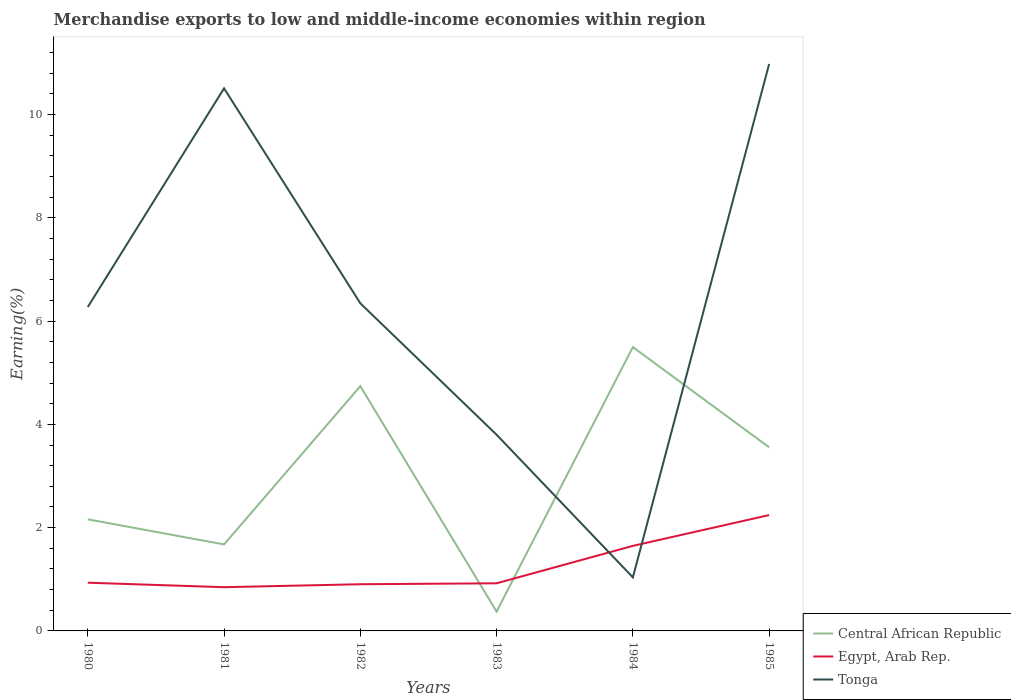Across all years, what is the maximum percentage of amount earned from merchandise exports in Egypt, Arab Rep.?
Provide a short and direct response. 0.85. What is the total percentage of amount earned from merchandise exports in Central African Republic in the graph?
Offer a terse response. 0.49. What is the difference between the highest and the second highest percentage of amount earned from merchandise exports in Central African Republic?
Ensure brevity in your answer.  5.12. Is the percentage of amount earned from merchandise exports in Tonga strictly greater than the percentage of amount earned from merchandise exports in Central African Republic over the years?
Your answer should be very brief. No. How many lines are there?
Offer a very short reply. 3. How many years are there in the graph?
Your response must be concise. 6. Does the graph contain any zero values?
Ensure brevity in your answer.  No. Does the graph contain grids?
Ensure brevity in your answer.  No. How are the legend labels stacked?
Your response must be concise. Vertical. What is the title of the graph?
Keep it short and to the point. Merchandise exports to low and middle-income economies within region. What is the label or title of the Y-axis?
Your response must be concise. Earning(%). What is the Earning(%) in Central African Republic in 1980?
Provide a short and direct response. 2.16. What is the Earning(%) in Egypt, Arab Rep. in 1980?
Provide a short and direct response. 0.93. What is the Earning(%) of Tonga in 1980?
Keep it short and to the point. 6.27. What is the Earning(%) of Central African Republic in 1981?
Offer a very short reply. 1.68. What is the Earning(%) in Egypt, Arab Rep. in 1981?
Your answer should be compact. 0.85. What is the Earning(%) of Tonga in 1981?
Provide a short and direct response. 10.51. What is the Earning(%) of Central African Republic in 1982?
Make the answer very short. 4.74. What is the Earning(%) of Egypt, Arab Rep. in 1982?
Provide a short and direct response. 0.9. What is the Earning(%) in Tonga in 1982?
Offer a very short reply. 6.34. What is the Earning(%) of Central African Republic in 1983?
Keep it short and to the point. 0.37. What is the Earning(%) in Egypt, Arab Rep. in 1983?
Keep it short and to the point. 0.92. What is the Earning(%) in Tonga in 1983?
Provide a short and direct response. 3.8. What is the Earning(%) of Central African Republic in 1984?
Your answer should be very brief. 5.5. What is the Earning(%) of Egypt, Arab Rep. in 1984?
Keep it short and to the point. 1.65. What is the Earning(%) in Tonga in 1984?
Your response must be concise. 1.04. What is the Earning(%) in Central African Republic in 1985?
Keep it short and to the point. 3.56. What is the Earning(%) of Egypt, Arab Rep. in 1985?
Offer a terse response. 2.24. What is the Earning(%) of Tonga in 1985?
Make the answer very short. 10.98. Across all years, what is the maximum Earning(%) of Central African Republic?
Make the answer very short. 5.5. Across all years, what is the maximum Earning(%) of Egypt, Arab Rep.?
Give a very brief answer. 2.24. Across all years, what is the maximum Earning(%) in Tonga?
Offer a terse response. 10.98. Across all years, what is the minimum Earning(%) of Central African Republic?
Provide a short and direct response. 0.37. Across all years, what is the minimum Earning(%) of Egypt, Arab Rep.?
Your answer should be compact. 0.85. Across all years, what is the minimum Earning(%) of Tonga?
Your answer should be very brief. 1.04. What is the total Earning(%) in Central African Republic in the graph?
Keep it short and to the point. 18. What is the total Earning(%) in Egypt, Arab Rep. in the graph?
Make the answer very short. 7.5. What is the total Earning(%) of Tonga in the graph?
Keep it short and to the point. 38.94. What is the difference between the Earning(%) of Central African Republic in 1980 and that in 1981?
Offer a terse response. 0.49. What is the difference between the Earning(%) of Egypt, Arab Rep. in 1980 and that in 1981?
Provide a succinct answer. 0.09. What is the difference between the Earning(%) of Tonga in 1980 and that in 1981?
Your response must be concise. -4.24. What is the difference between the Earning(%) of Central African Republic in 1980 and that in 1982?
Provide a short and direct response. -2.58. What is the difference between the Earning(%) of Egypt, Arab Rep. in 1980 and that in 1982?
Ensure brevity in your answer.  0.03. What is the difference between the Earning(%) in Tonga in 1980 and that in 1982?
Offer a terse response. -0.07. What is the difference between the Earning(%) in Central African Republic in 1980 and that in 1983?
Your answer should be very brief. 1.79. What is the difference between the Earning(%) of Egypt, Arab Rep. in 1980 and that in 1983?
Offer a very short reply. 0.01. What is the difference between the Earning(%) of Tonga in 1980 and that in 1983?
Your answer should be very brief. 2.47. What is the difference between the Earning(%) of Central African Republic in 1980 and that in 1984?
Your response must be concise. -3.34. What is the difference between the Earning(%) of Egypt, Arab Rep. in 1980 and that in 1984?
Provide a succinct answer. -0.71. What is the difference between the Earning(%) of Tonga in 1980 and that in 1984?
Provide a short and direct response. 5.24. What is the difference between the Earning(%) in Central African Republic in 1980 and that in 1985?
Ensure brevity in your answer.  -1.39. What is the difference between the Earning(%) of Egypt, Arab Rep. in 1980 and that in 1985?
Offer a terse response. -1.31. What is the difference between the Earning(%) of Tonga in 1980 and that in 1985?
Your answer should be very brief. -4.71. What is the difference between the Earning(%) in Central African Republic in 1981 and that in 1982?
Provide a short and direct response. -3.07. What is the difference between the Earning(%) in Egypt, Arab Rep. in 1981 and that in 1982?
Your answer should be compact. -0.06. What is the difference between the Earning(%) of Tonga in 1981 and that in 1982?
Ensure brevity in your answer.  4.16. What is the difference between the Earning(%) in Central African Republic in 1981 and that in 1983?
Offer a very short reply. 1.3. What is the difference between the Earning(%) in Egypt, Arab Rep. in 1981 and that in 1983?
Keep it short and to the point. -0.08. What is the difference between the Earning(%) in Tonga in 1981 and that in 1983?
Provide a succinct answer. 6.71. What is the difference between the Earning(%) in Central African Republic in 1981 and that in 1984?
Offer a very short reply. -3.82. What is the difference between the Earning(%) of Egypt, Arab Rep. in 1981 and that in 1984?
Provide a succinct answer. -0.8. What is the difference between the Earning(%) in Tonga in 1981 and that in 1984?
Your response must be concise. 9.47. What is the difference between the Earning(%) in Central African Republic in 1981 and that in 1985?
Provide a short and direct response. -1.88. What is the difference between the Earning(%) in Egypt, Arab Rep. in 1981 and that in 1985?
Make the answer very short. -1.4. What is the difference between the Earning(%) in Tonga in 1981 and that in 1985?
Keep it short and to the point. -0.47. What is the difference between the Earning(%) in Central African Republic in 1982 and that in 1983?
Offer a terse response. 4.37. What is the difference between the Earning(%) in Egypt, Arab Rep. in 1982 and that in 1983?
Your answer should be very brief. -0.02. What is the difference between the Earning(%) of Tonga in 1982 and that in 1983?
Offer a very short reply. 2.55. What is the difference between the Earning(%) of Central African Republic in 1982 and that in 1984?
Give a very brief answer. -0.76. What is the difference between the Earning(%) of Egypt, Arab Rep. in 1982 and that in 1984?
Your response must be concise. -0.74. What is the difference between the Earning(%) in Tonga in 1982 and that in 1984?
Make the answer very short. 5.31. What is the difference between the Earning(%) of Central African Republic in 1982 and that in 1985?
Offer a terse response. 1.18. What is the difference between the Earning(%) in Egypt, Arab Rep. in 1982 and that in 1985?
Offer a terse response. -1.34. What is the difference between the Earning(%) of Tonga in 1982 and that in 1985?
Provide a succinct answer. -4.64. What is the difference between the Earning(%) of Central African Republic in 1983 and that in 1984?
Provide a short and direct response. -5.12. What is the difference between the Earning(%) in Egypt, Arab Rep. in 1983 and that in 1984?
Ensure brevity in your answer.  -0.72. What is the difference between the Earning(%) in Tonga in 1983 and that in 1984?
Your answer should be very brief. 2.76. What is the difference between the Earning(%) of Central African Republic in 1983 and that in 1985?
Your answer should be very brief. -3.18. What is the difference between the Earning(%) in Egypt, Arab Rep. in 1983 and that in 1985?
Offer a terse response. -1.32. What is the difference between the Earning(%) of Tonga in 1983 and that in 1985?
Offer a very short reply. -7.18. What is the difference between the Earning(%) in Central African Republic in 1984 and that in 1985?
Offer a very short reply. 1.94. What is the difference between the Earning(%) in Egypt, Arab Rep. in 1984 and that in 1985?
Make the answer very short. -0.6. What is the difference between the Earning(%) in Tonga in 1984 and that in 1985?
Offer a terse response. -9.94. What is the difference between the Earning(%) of Central African Republic in 1980 and the Earning(%) of Egypt, Arab Rep. in 1981?
Your answer should be compact. 1.31. What is the difference between the Earning(%) of Central African Republic in 1980 and the Earning(%) of Tonga in 1981?
Keep it short and to the point. -8.35. What is the difference between the Earning(%) in Egypt, Arab Rep. in 1980 and the Earning(%) in Tonga in 1981?
Make the answer very short. -9.57. What is the difference between the Earning(%) of Central African Republic in 1980 and the Earning(%) of Egypt, Arab Rep. in 1982?
Ensure brevity in your answer.  1.26. What is the difference between the Earning(%) in Central African Republic in 1980 and the Earning(%) in Tonga in 1982?
Your answer should be compact. -4.18. What is the difference between the Earning(%) of Egypt, Arab Rep. in 1980 and the Earning(%) of Tonga in 1982?
Your answer should be very brief. -5.41. What is the difference between the Earning(%) of Central African Republic in 1980 and the Earning(%) of Egypt, Arab Rep. in 1983?
Your answer should be compact. 1.24. What is the difference between the Earning(%) of Central African Republic in 1980 and the Earning(%) of Tonga in 1983?
Make the answer very short. -1.64. What is the difference between the Earning(%) of Egypt, Arab Rep. in 1980 and the Earning(%) of Tonga in 1983?
Make the answer very short. -2.87. What is the difference between the Earning(%) of Central African Republic in 1980 and the Earning(%) of Egypt, Arab Rep. in 1984?
Give a very brief answer. 0.51. What is the difference between the Earning(%) in Central African Republic in 1980 and the Earning(%) in Tonga in 1984?
Your answer should be very brief. 1.12. What is the difference between the Earning(%) in Egypt, Arab Rep. in 1980 and the Earning(%) in Tonga in 1984?
Keep it short and to the point. -0.1. What is the difference between the Earning(%) of Central African Republic in 1980 and the Earning(%) of Egypt, Arab Rep. in 1985?
Your answer should be very brief. -0.08. What is the difference between the Earning(%) in Central African Republic in 1980 and the Earning(%) in Tonga in 1985?
Give a very brief answer. -8.82. What is the difference between the Earning(%) in Egypt, Arab Rep. in 1980 and the Earning(%) in Tonga in 1985?
Provide a succinct answer. -10.05. What is the difference between the Earning(%) in Central African Republic in 1981 and the Earning(%) in Egypt, Arab Rep. in 1982?
Provide a succinct answer. 0.77. What is the difference between the Earning(%) in Central African Republic in 1981 and the Earning(%) in Tonga in 1982?
Your answer should be very brief. -4.67. What is the difference between the Earning(%) in Egypt, Arab Rep. in 1981 and the Earning(%) in Tonga in 1982?
Make the answer very short. -5.5. What is the difference between the Earning(%) of Central African Republic in 1981 and the Earning(%) of Egypt, Arab Rep. in 1983?
Give a very brief answer. 0.75. What is the difference between the Earning(%) in Central African Republic in 1981 and the Earning(%) in Tonga in 1983?
Your answer should be very brief. -2.12. What is the difference between the Earning(%) in Egypt, Arab Rep. in 1981 and the Earning(%) in Tonga in 1983?
Offer a terse response. -2.95. What is the difference between the Earning(%) in Central African Republic in 1981 and the Earning(%) in Egypt, Arab Rep. in 1984?
Provide a succinct answer. 0.03. What is the difference between the Earning(%) of Central African Republic in 1981 and the Earning(%) of Tonga in 1984?
Your answer should be very brief. 0.64. What is the difference between the Earning(%) in Egypt, Arab Rep. in 1981 and the Earning(%) in Tonga in 1984?
Make the answer very short. -0.19. What is the difference between the Earning(%) of Central African Republic in 1981 and the Earning(%) of Egypt, Arab Rep. in 1985?
Keep it short and to the point. -0.57. What is the difference between the Earning(%) in Central African Republic in 1981 and the Earning(%) in Tonga in 1985?
Give a very brief answer. -9.31. What is the difference between the Earning(%) of Egypt, Arab Rep. in 1981 and the Earning(%) of Tonga in 1985?
Keep it short and to the point. -10.13. What is the difference between the Earning(%) in Central African Republic in 1982 and the Earning(%) in Egypt, Arab Rep. in 1983?
Offer a very short reply. 3.82. What is the difference between the Earning(%) of Central African Republic in 1982 and the Earning(%) of Tonga in 1983?
Make the answer very short. 0.94. What is the difference between the Earning(%) of Egypt, Arab Rep. in 1982 and the Earning(%) of Tonga in 1983?
Offer a terse response. -2.9. What is the difference between the Earning(%) of Central African Republic in 1982 and the Earning(%) of Egypt, Arab Rep. in 1984?
Offer a very short reply. 3.09. What is the difference between the Earning(%) of Central African Republic in 1982 and the Earning(%) of Tonga in 1984?
Ensure brevity in your answer.  3.7. What is the difference between the Earning(%) of Egypt, Arab Rep. in 1982 and the Earning(%) of Tonga in 1984?
Your answer should be very brief. -0.13. What is the difference between the Earning(%) in Central African Republic in 1982 and the Earning(%) in Egypt, Arab Rep. in 1985?
Keep it short and to the point. 2.5. What is the difference between the Earning(%) of Central African Republic in 1982 and the Earning(%) of Tonga in 1985?
Provide a succinct answer. -6.24. What is the difference between the Earning(%) of Egypt, Arab Rep. in 1982 and the Earning(%) of Tonga in 1985?
Offer a very short reply. -10.08. What is the difference between the Earning(%) of Central African Republic in 1983 and the Earning(%) of Egypt, Arab Rep. in 1984?
Provide a succinct answer. -1.27. What is the difference between the Earning(%) in Central African Republic in 1983 and the Earning(%) in Tonga in 1984?
Offer a terse response. -0.66. What is the difference between the Earning(%) of Egypt, Arab Rep. in 1983 and the Earning(%) of Tonga in 1984?
Offer a terse response. -0.11. What is the difference between the Earning(%) of Central African Republic in 1983 and the Earning(%) of Egypt, Arab Rep. in 1985?
Ensure brevity in your answer.  -1.87. What is the difference between the Earning(%) in Central African Republic in 1983 and the Earning(%) in Tonga in 1985?
Offer a very short reply. -10.61. What is the difference between the Earning(%) in Egypt, Arab Rep. in 1983 and the Earning(%) in Tonga in 1985?
Your response must be concise. -10.06. What is the difference between the Earning(%) in Central African Republic in 1984 and the Earning(%) in Egypt, Arab Rep. in 1985?
Your response must be concise. 3.25. What is the difference between the Earning(%) in Central African Republic in 1984 and the Earning(%) in Tonga in 1985?
Keep it short and to the point. -5.48. What is the difference between the Earning(%) in Egypt, Arab Rep. in 1984 and the Earning(%) in Tonga in 1985?
Give a very brief answer. -9.33. What is the average Earning(%) of Central African Republic per year?
Make the answer very short. 3. What is the average Earning(%) of Egypt, Arab Rep. per year?
Offer a very short reply. 1.25. What is the average Earning(%) in Tonga per year?
Offer a terse response. 6.49. In the year 1980, what is the difference between the Earning(%) of Central African Republic and Earning(%) of Egypt, Arab Rep.?
Offer a very short reply. 1.23. In the year 1980, what is the difference between the Earning(%) in Central African Republic and Earning(%) in Tonga?
Offer a very short reply. -4.11. In the year 1980, what is the difference between the Earning(%) in Egypt, Arab Rep. and Earning(%) in Tonga?
Ensure brevity in your answer.  -5.34. In the year 1981, what is the difference between the Earning(%) in Central African Republic and Earning(%) in Egypt, Arab Rep.?
Keep it short and to the point. 0.83. In the year 1981, what is the difference between the Earning(%) in Central African Republic and Earning(%) in Tonga?
Your answer should be very brief. -8.83. In the year 1981, what is the difference between the Earning(%) of Egypt, Arab Rep. and Earning(%) of Tonga?
Offer a very short reply. -9.66. In the year 1982, what is the difference between the Earning(%) in Central African Republic and Earning(%) in Egypt, Arab Rep.?
Keep it short and to the point. 3.84. In the year 1982, what is the difference between the Earning(%) in Central African Republic and Earning(%) in Tonga?
Keep it short and to the point. -1.6. In the year 1982, what is the difference between the Earning(%) of Egypt, Arab Rep. and Earning(%) of Tonga?
Give a very brief answer. -5.44. In the year 1983, what is the difference between the Earning(%) in Central African Republic and Earning(%) in Egypt, Arab Rep.?
Give a very brief answer. -0.55. In the year 1983, what is the difference between the Earning(%) of Central African Republic and Earning(%) of Tonga?
Your answer should be compact. -3.43. In the year 1983, what is the difference between the Earning(%) in Egypt, Arab Rep. and Earning(%) in Tonga?
Offer a very short reply. -2.88. In the year 1984, what is the difference between the Earning(%) in Central African Republic and Earning(%) in Egypt, Arab Rep.?
Provide a short and direct response. 3.85. In the year 1984, what is the difference between the Earning(%) in Central African Republic and Earning(%) in Tonga?
Provide a succinct answer. 4.46. In the year 1984, what is the difference between the Earning(%) of Egypt, Arab Rep. and Earning(%) of Tonga?
Provide a succinct answer. 0.61. In the year 1985, what is the difference between the Earning(%) of Central African Republic and Earning(%) of Egypt, Arab Rep.?
Your response must be concise. 1.31. In the year 1985, what is the difference between the Earning(%) in Central African Republic and Earning(%) in Tonga?
Give a very brief answer. -7.42. In the year 1985, what is the difference between the Earning(%) in Egypt, Arab Rep. and Earning(%) in Tonga?
Give a very brief answer. -8.74. What is the ratio of the Earning(%) in Central African Republic in 1980 to that in 1981?
Provide a succinct answer. 1.29. What is the ratio of the Earning(%) of Egypt, Arab Rep. in 1980 to that in 1981?
Make the answer very short. 1.1. What is the ratio of the Earning(%) of Tonga in 1980 to that in 1981?
Make the answer very short. 0.6. What is the ratio of the Earning(%) in Central African Republic in 1980 to that in 1982?
Give a very brief answer. 0.46. What is the ratio of the Earning(%) of Egypt, Arab Rep. in 1980 to that in 1982?
Your response must be concise. 1.03. What is the ratio of the Earning(%) in Tonga in 1980 to that in 1982?
Provide a succinct answer. 0.99. What is the ratio of the Earning(%) in Central African Republic in 1980 to that in 1983?
Give a very brief answer. 5.77. What is the ratio of the Earning(%) of Egypt, Arab Rep. in 1980 to that in 1983?
Provide a short and direct response. 1.01. What is the ratio of the Earning(%) in Tonga in 1980 to that in 1983?
Provide a succinct answer. 1.65. What is the ratio of the Earning(%) of Central African Republic in 1980 to that in 1984?
Your answer should be very brief. 0.39. What is the ratio of the Earning(%) of Egypt, Arab Rep. in 1980 to that in 1984?
Offer a very short reply. 0.57. What is the ratio of the Earning(%) in Tonga in 1980 to that in 1984?
Your answer should be compact. 6.05. What is the ratio of the Earning(%) of Central African Republic in 1980 to that in 1985?
Ensure brevity in your answer.  0.61. What is the ratio of the Earning(%) in Egypt, Arab Rep. in 1980 to that in 1985?
Provide a short and direct response. 0.42. What is the ratio of the Earning(%) of Tonga in 1980 to that in 1985?
Provide a short and direct response. 0.57. What is the ratio of the Earning(%) in Central African Republic in 1981 to that in 1982?
Offer a very short reply. 0.35. What is the ratio of the Earning(%) of Egypt, Arab Rep. in 1981 to that in 1982?
Your answer should be compact. 0.94. What is the ratio of the Earning(%) in Tonga in 1981 to that in 1982?
Ensure brevity in your answer.  1.66. What is the ratio of the Earning(%) in Central African Republic in 1981 to that in 1983?
Give a very brief answer. 4.47. What is the ratio of the Earning(%) in Egypt, Arab Rep. in 1981 to that in 1983?
Your answer should be very brief. 0.92. What is the ratio of the Earning(%) of Tonga in 1981 to that in 1983?
Make the answer very short. 2.77. What is the ratio of the Earning(%) in Central African Republic in 1981 to that in 1984?
Offer a very short reply. 0.3. What is the ratio of the Earning(%) of Egypt, Arab Rep. in 1981 to that in 1984?
Keep it short and to the point. 0.51. What is the ratio of the Earning(%) in Tonga in 1981 to that in 1984?
Give a very brief answer. 10.13. What is the ratio of the Earning(%) of Central African Republic in 1981 to that in 1985?
Provide a succinct answer. 0.47. What is the ratio of the Earning(%) in Egypt, Arab Rep. in 1981 to that in 1985?
Give a very brief answer. 0.38. What is the ratio of the Earning(%) in Tonga in 1981 to that in 1985?
Ensure brevity in your answer.  0.96. What is the ratio of the Earning(%) of Central African Republic in 1982 to that in 1983?
Provide a succinct answer. 12.66. What is the ratio of the Earning(%) of Egypt, Arab Rep. in 1982 to that in 1983?
Make the answer very short. 0.98. What is the ratio of the Earning(%) in Tonga in 1982 to that in 1983?
Offer a very short reply. 1.67. What is the ratio of the Earning(%) in Central African Republic in 1982 to that in 1984?
Make the answer very short. 0.86. What is the ratio of the Earning(%) of Egypt, Arab Rep. in 1982 to that in 1984?
Your answer should be compact. 0.55. What is the ratio of the Earning(%) in Tonga in 1982 to that in 1984?
Your response must be concise. 6.12. What is the ratio of the Earning(%) of Central African Republic in 1982 to that in 1985?
Make the answer very short. 1.33. What is the ratio of the Earning(%) of Egypt, Arab Rep. in 1982 to that in 1985?
Provide a short and direct response. 0.4. What is the ratio of the Earning(%) of Tonga in 1982 to that in 1985?
Ensure brevity in your answer.  0.58. What is the ratio of the Earning(%) in Central African Republic in 1983 to that in 1984?
Provide a short and direct response. 0.07. What is the ratio of the Earning(%) of Egypt, Arab Rep. in 1983 to that in 1984?
Provide a succinct answer. 0.56. What is the ratio of the Earning(%) in Tonga in 1983 to that in 1984?
Ensure brevity in your answer.  3.66. What is the ratio of the Earning(%) of Central African Republic in 1983 to that in 1985?
Provide a short and direct response. 0.11. What is the ratio of the Earning(%) in Egypt, Arab Rep. in 1983 to that in 1985?
Offer a terse response. 0.41. What is the ratio of the Earning(%) of Tonga in 1983 to that in 1985?
Provide a succinct answer. 0.35. What is the ratio of the Earning(%) of Central African Republic in 1984 to that in 1985?
Offer a very short reply. 1.55. What is the ratio of the Earning(%) in Egypt, Arab Rep. in 1984 to that in 1985?
Give a very brief answer. 0.73. What is the ratio of the Earning(%) in Tonga in 1984 to that in 1985?
Your response must be concise. 0.09. What is the difference between the highest and the second highest Earning(%) of Central African Republic?
Ensure brevity in your answer.  0.76. What is the difference between the highest and the second highest Earning(%) in Egypt, Arab Rep.?
Provide a short and direct response. 0.6. What is the difference between the highest and the second highest Earning(%) of Tonga?
Make the answer very short. 0.47. What is the difference between the highest and the lowest Earning(%) in Central African Republic?
Make the answer very short. 5.12. What is the difference between the highest and the lowest Earning(%) of Egypt, Arab Rep.?
Ensure brevity in your answer.  1.4. What is the difference between the highest and the lowest Earning(%) of Tonga?
Your answer should be compact. 9.94. 